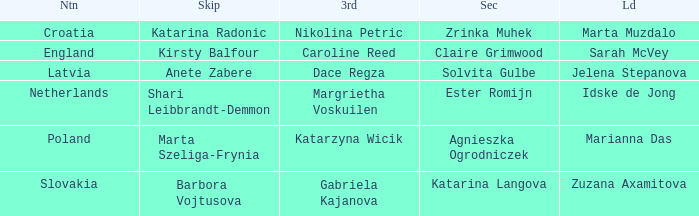Which Lead has Katarina Radonic as Skip? Marta Muzdalo. 